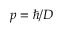<formula> <loc_0><loc_0><loc_500><loc_500>p = \hbar { / } D</formula> 